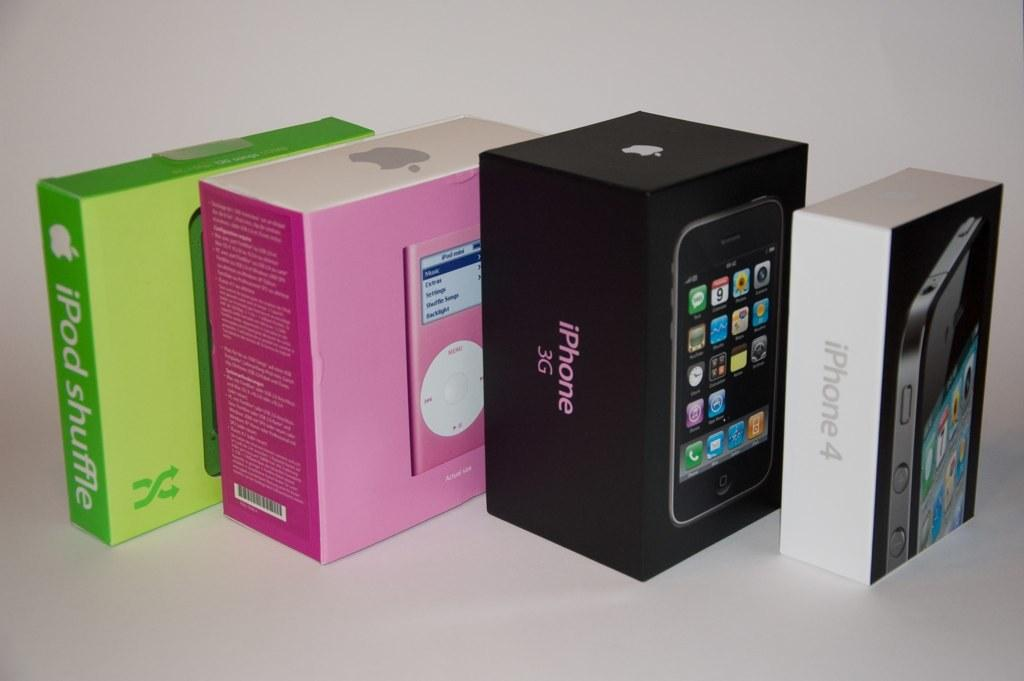Provide a one-sentence caption for the provided image. A black iPhone 3G box sits next to a pink iPod box. 